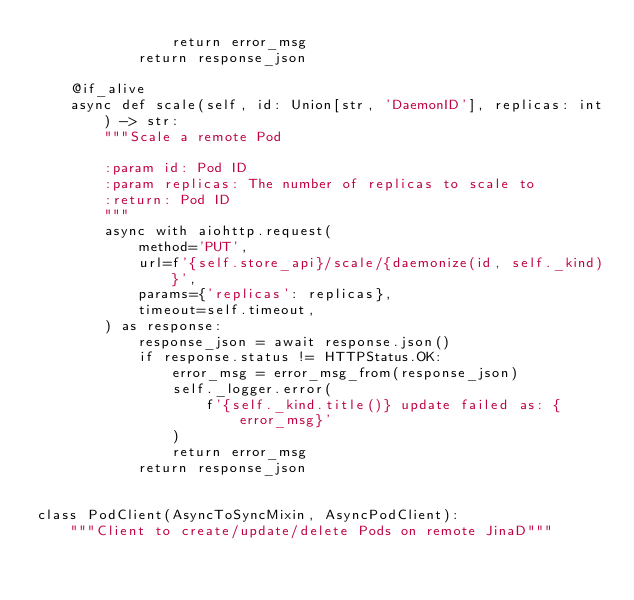<code> <loc_0><loc_0><loc_500><loc_500><_Python_>                return error_msg
            return response_json

    @if_alive
    async def scale(self, id: Union[str, 'DaemonID'], replicas: int) -> str:
        """Scale a remote Pod

        :param id: Pod ID
        :param replicas: The number of replicas to scale to
        :return: Pod ID
        """
        async with aiohttp.request(
            method='PUT',
            url=f'{self.store_api}/scale/{daemonize(id, self._kind)}',
            params={'replicas': replicas},
            timeout=self.timeout,
        ) as response:
            response_json = await response.json()
            if response.status != HTTPStatus.OK:
                error_msg = error_msg_from(response_json)
                self._logger.error(
                    f'{self._kind.title()} update failed as: {error_msg}'
                )
                return error_msg
            return response_json


class PodClient(AsyncToSyncMixin, AsyncPodClient):
    """Client to create/update/delete Pods on remote JinaD"""
</code> 